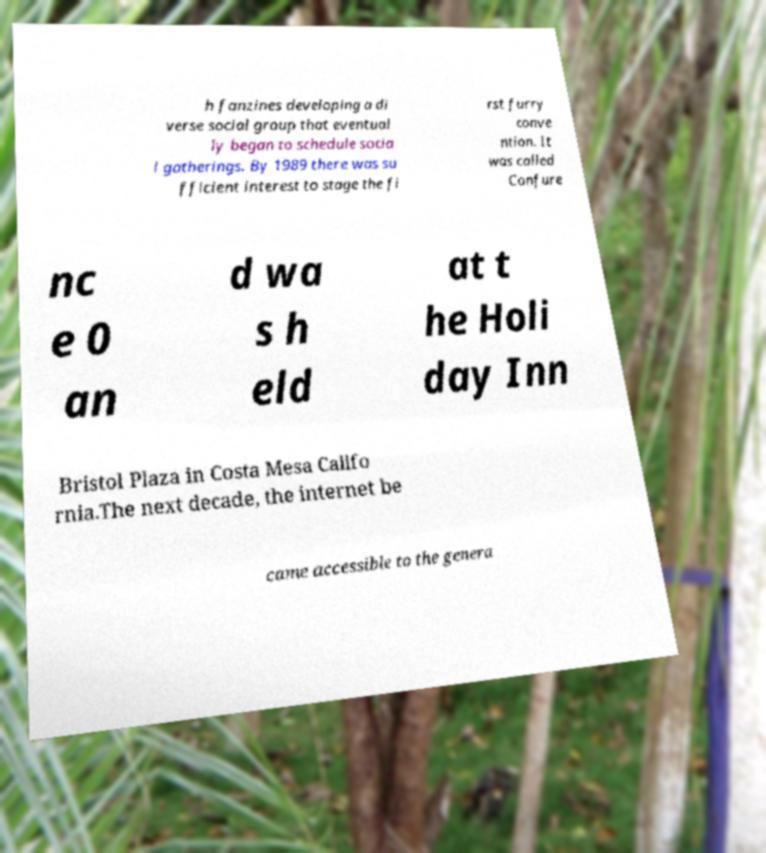Can you read and provide the text displayed in the image?This photo seems to have some interesting text. Can you extract and type it out for me? h fanzines developing a di verse social group that eventual ly began to schedule socia l gatherings. By 1989 there was su fficient interest to stage the fi rst furry conve ntion. It was called Confure nc e 0 an d wa s h eld at t he Holi day Inn Bristol Plaza in Costa Mesa Califo rnia.The next decade, the internet be came accessible to the genera 